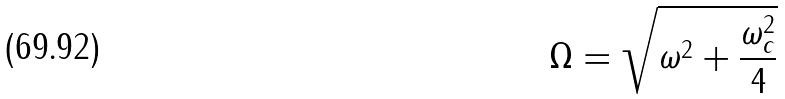Convert formula to latex. <formula><loc_0><loc_0><loc_500><loc_500>\Omega = \sqrt { \omega ^ { 2 } + \frac { \omega _ { c } ^ { 2 } } { 4 } }</formula> 